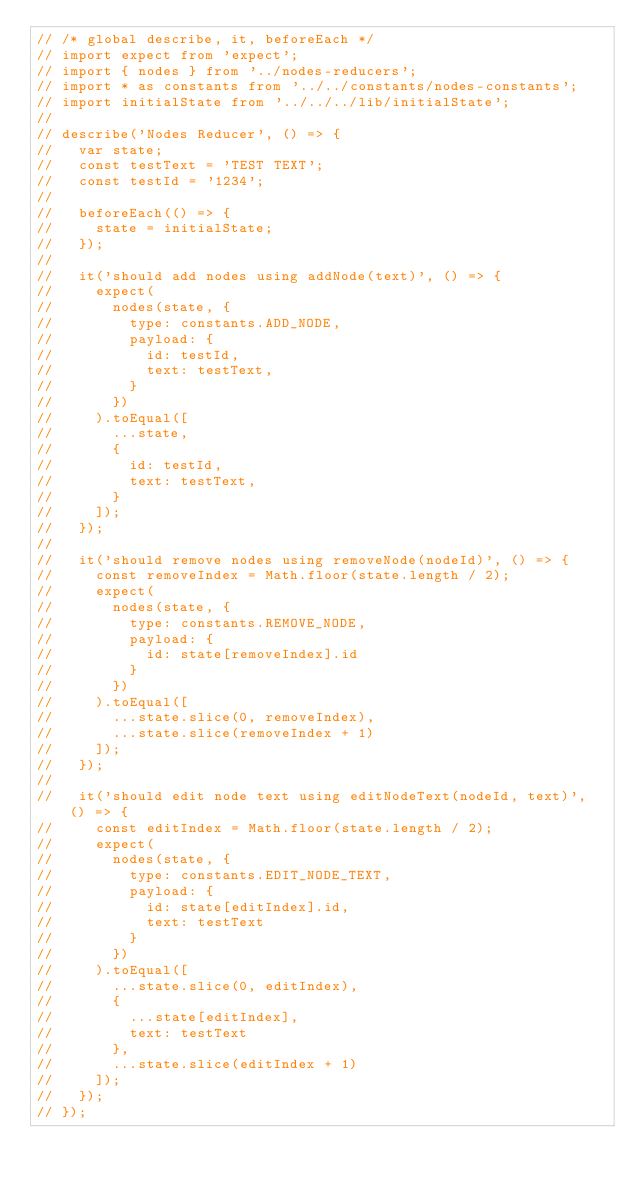<code> <loc_0><loc_0><loc_500><loc_500><_JavaScript_>// /* global describe, it, beforeEach */
// import expect from 'expect';
// import { nodes } from '../nodes-reducers';
// import * as constants from '../../constants/nodes-constants';
// import initialState from '../../../lib/initialState';
//
// describe('Nodes Reducer', () => {
//   var state;
//   const testText = 'TEST TEXT';
//   const testId = '1234';
//
//   beforeEach(() => {
//     state = initialState;
//   });
//
//   it('should add nodes using addNode(text)', () => {
//     expect(
//       nodes(state, {
//         type: constants.ADD_NODE,
//         payload: {
//           id: testId,
//           text: testText,
//         }
//       })
//     ).toEqual([
//       ...state,
//       {
//         id: testId,
//         text: testText,
//       }
//     ]);
//   });
//
//   it('should remove nodes using removeNode(nodeId)', () => {
//     const removeIndex = Math.floor(state.length / 2);
//     expect(
//       nodes(state, {
//         type: constants.REMOVE_NODE,
//         payload: {
//           id: state[removeIndex].id
//         }
//       })
//     ).toEqual([
//       ...state.slice(0, removeIndex),
//       ...state.slice(removeIndex + 1)
//     ]);
//   });
//
//   it('should edit node text using editNodeText(nodeId, text)', () => {
//     const editIndex = Math.floor(state.length / 2);
//     expect(
//       nodes(state, {
//         type: constants.EDIT_NODE_TEXT,
//         payload: {
//           id: state[editIndex].id,
//           text: testText
//         }
//       })
//     ).toEqual([
//       ...state.slice(0, editIndex),
//       {
//         ...state[editIndex],
//         text: testText
//       },
//       ...state.slice(editIndex + 1)
//     ]);
//   });
// });
</code> 